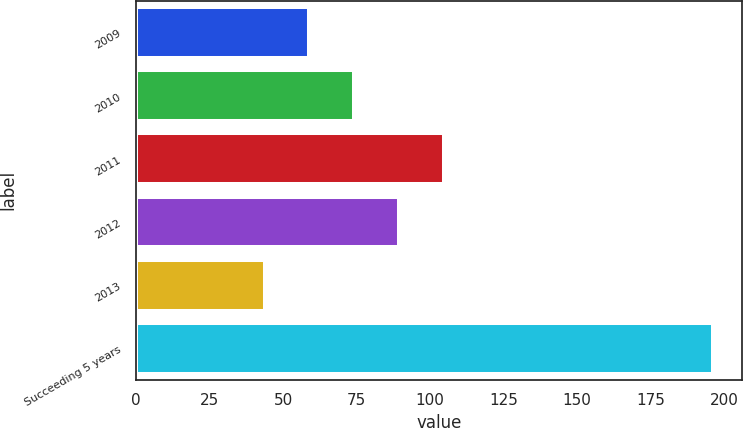<chart> <loc_0><loc_0><loc_500><loc_500><bar_chart><fcel>2009<fcel>2010<fcel>2011<fcel>2012<fcel>2013<fcel>Succeeding 5 years<nl><fcel>58.95<fcel>74.2<fcel>104.7<fcel>89.45<fcel>43.7<fcel>196.2<nl></chart> 